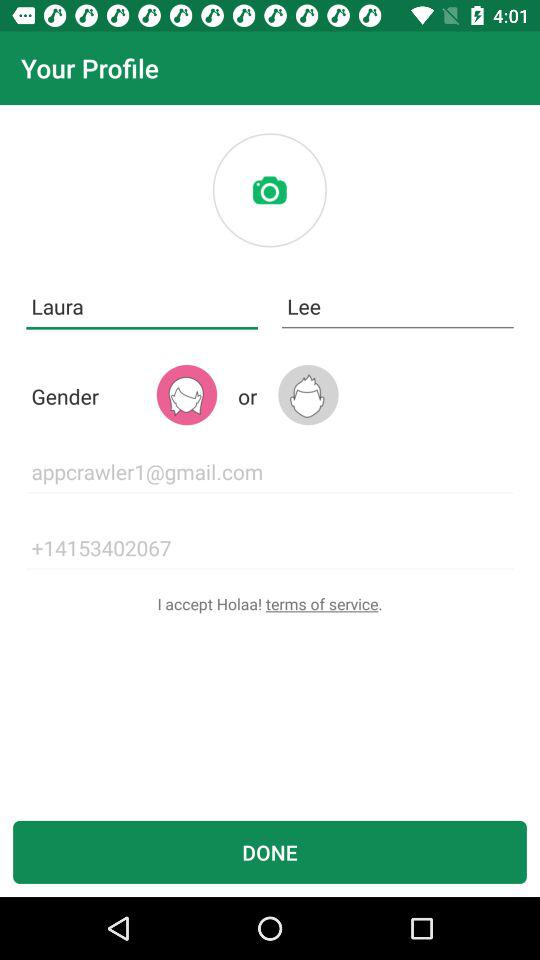What is the user's first name? The user's first name is Laura. 